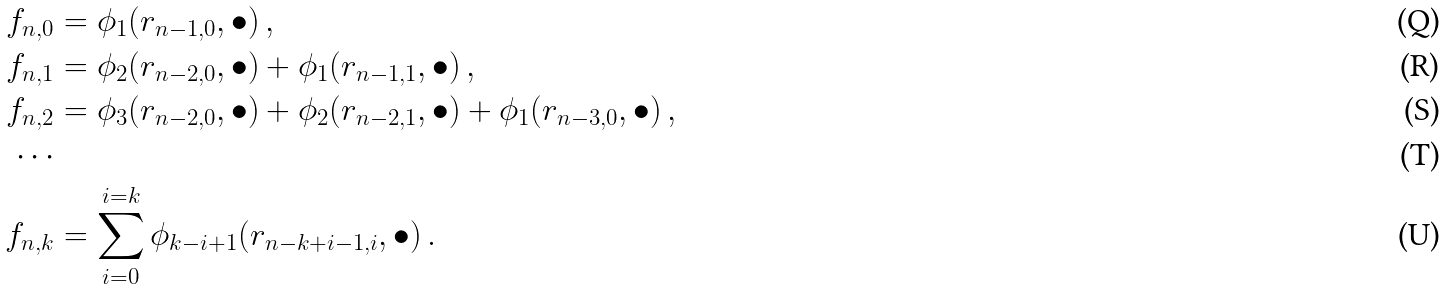Convert formula to latex. <formula><loc_0><loc_0><loc_500><loc_500>f _ { n , 0 } & = \phi _ { 1 } ( r _ { n - 1 , 0 } , \bullet ) \, , \\ f _ { n , 1 } & = \phi _ { 2 } ( r _ { n - 2 , 0 } , \bullet ) + \phi _ { 1 } ( r _ { n - 1 , 1 } , \bullet ) \, , \\ f _ { n , 2 } & = \phi _ { 3 } ( r _ { n - 2 , 0 } , \bullet ) + \phi _ { 2 } ( r _ { n - 2 , 1 } , \bullet ) + \phi _ { 1 } ( r _ { n - 3 , 0 } , \bullet ) \, , \\ \cdots & \\ f _ { n , k } & = \sum _ { i = 0 } ^ { i = k } \phi _ { k - i + 1 } ( r _ { n - k + i - 1 , i } , \bullet ) \, .</formula> 